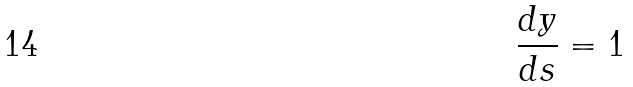<formula> <loc_0><loc_0><loc_500><loc_500>\frac { d y } { d s } = 1</formula> 